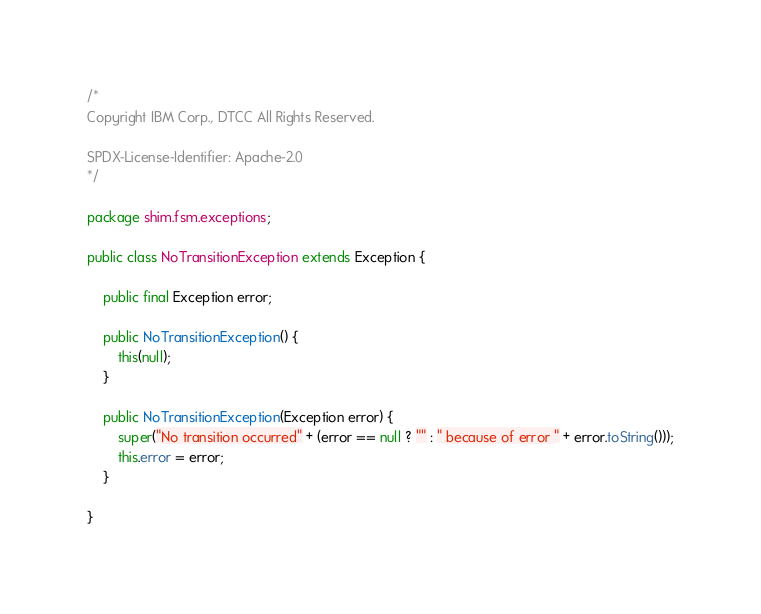<code> <loc_0><loc_0><loc_500><loc_500><_Java_>/*
Copyright IBM Corp., DTCC All Rights Reserved.

SPDX-License-Identifier: Apache-2.0
*/

package shim.fsm.exceptions;

public class NoTransitionException extends Exception {

	public final Exception error;

	public NoTransitionException() {
		this(null);
	}

	public NoTransitionException(Exception error) {
		super("No transition occurred" + (error == null ? "" : " because of error " + error.toString()));
		this.error = error;
	}

}
</code> 